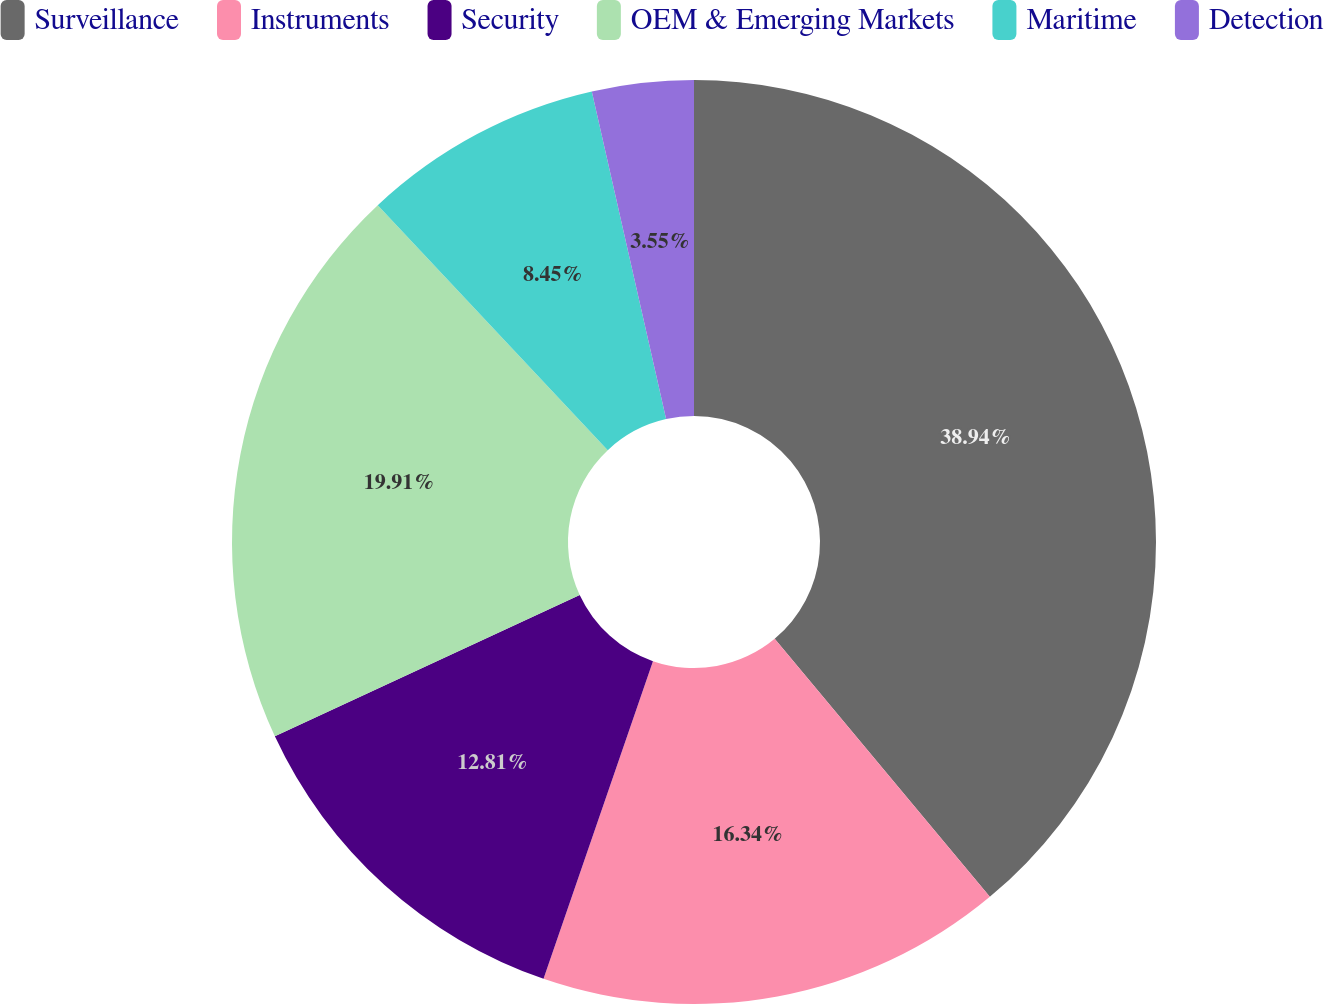Convert chart to OTSL. <chart><loc_0><loc_0><loc_500><loc_500><pie_chart><fcel>Surveillance<fcel>Instruments<fcel>Security<fcel>OEM & Emerging Markets<fcel>Maritime<fcel>Detection<nl><fcel>38.94%<fcel>16.34%<fcel>12.81%<fcel>19.91%<fcel>8.45%<fcel>3.55%<nl></chart> 